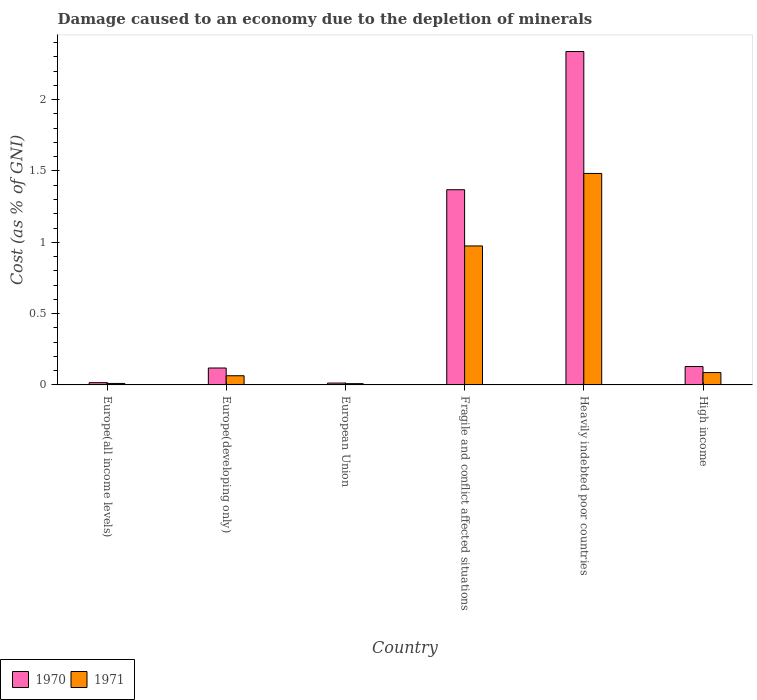How many different coloured bars are there?
Your answer should be compact. 2. Are the number of bars on each tick of the X-axis equal?
Provide a succinct answer. Yes. What is the label of the 4th group of bars from the left?
Your answer should be very brief. Fragile and conflict affected situations. What is the cost of damage caused due to the depletion of minerals in 1970 in Heavily indebted poor countries?
Keep it short and to the point. 2.34. Across all countries, what is the maximum cost of damage caused due to the depletion of minerals in 1971?
Make the answer very short. 1.48. Across all countries, what is the minimum cost of damage caused due to the depletion of minerals in 1971?
Ensure brevity in your answer.  0.01. In which country was the cost of damage caused due to the depletion of minerals in 1971 maximum?
Ensure brevity in your answer.  Heavily indebted poor countries. In which country was the cost of damage caused due to the depletion of minerals in 1971 minimum?
Give a very brief answer. European Union. What is the total cost of damage caused due to the depletion of minerals in 1971 in the graph?
Your answer should be very brief. 2.63. What is the difference between the cost of damage caused due to the depletion of minerals in 1970 in European Union and that in High income?
Your answer should be very brief. -0.12. What is the difference between the cost of damage caused due to the depletion of minerals in 1971 in Fragile and conflict affected situations and the cost of damage caused due to the depletion of minerals in 1970 in Europe(developing only)?
Make the answer very short. 0.86. What is the average cost of damage caused due to the depletion of minerals in 1971 per country?
Give a very brief answer. 0.44. What is the difference between the cost of damage caused due to the depletion of minerals of/in 1970 and cost of damage caused due to the depletion of minerals of/in 1971 in Heavily indebted poor countries?
Provide a succinct answer. 0.85. What is the ratio of the cost of damage caused due to the depletion of minerals in 1970 in Europe(all income levels) to that in High income?
Your answer should be compact. 0.12. Is the cost of damage caused due to the depletion of minerals in 1970 in Europe(developing only) less than that in Heavily indebted poor countries?
Offer a terse response. Yes. Is the difference between the cost of damage caused due to the depletion of minerals in 1970 in Europe(developing only) and European Union greater than the difference between the cost of damage caused due to the depletion of minerals in 1971 in Europe(developing only) and European Union?
Ensure brevity in your answer.  Yes. What is the difference between the highest and the second highest cost of damage caused due to the depletion of minerals in 1971?
Keep it short and to the point. -0.51. What is the difference between the highest and the lowest cost of damage caused due to the depletion of minerals in 1970?
Ensure brevity in your answer.  2.32. In how many countries, is the cost of damage caused due to the depletion of minerals in 1971 greater than the average cost of damage caused due to the depletion of minerals in 1971 taken over all countries?
Keep it short and to the point. 2. Is the sum of the cost of damage caused due to the depletion of minerals in 1970 in Europe(developing only) and High income greater than the maximum cost of damage caused due to the depletion of minerals in 1971 across all countries?
Offer a terse response. No. What does the 1st bar from the left in High income represents?
Offer a very short reply. 1970. Are all the bars in the graph horizontal?
Your answer should be very brief. No. What is the difference between two consecutive major ticks on the Y-axis?
Give a very brief answer. 0.5. Are the values on the major ticks of Y-axis written in scientific E-notation?
Keep it short and to the point. No. Does the graph contain grids?
Your answer should be compact. No. Where does the legend appear in the graph?
Provide a short and direct response. Bottom left. How many legend labels are there?
Ensure brevity in your answer.  2. How are the legend labels stacked?
Ensure brevity in your answer.  Horizontal. What is the title of the graph?
Keep it short and to the point. Damage caused to an economy due to the depletion of minerals. What is the label or title of the Y-axis?
Your answer should be very brief. Cost (as % of GNI). What is the Cost (as % of GNI) in 1970 in Europe(all income levels)?
Offer a very short reply. 0.02. What is the Cost (as % of GNI) in 1971 in Europe(all income levels)?
Your answer should be compact. 0.01. What is the Cost (as % of GNI) in 1970 in Europe(developing only)?
Provide a succinct answer. 0.12. What is the Cost (as % of GNI) in 1971 in Europe(developing only)?
Your response must be concise. 0.06. What is the Cost (as % of GNI) of 1970 in European Union?
Offer a very short reply. 0.01. What is the Cost (as % of GNI) in 1971 in European Union?
Ensure brevity in your answer.  0.01. What is the Cost (as % of GNI) in 1970 in Fragile and conflict affected situations?
Your answer should be compact. 1.37. What is the Cost (as % of GNI) of 1971 in Fragile and conflict affected situations?
Offer a terse response. 0.97. What is the Cost (as % of GNI) of 1970 in Heavily indebted poor countries?
Offer a very short reply. 2.34. What is the Cost (as % of GNI) of 1971 in Heavily indebted poor countries?
Keep it short and to the point. 1.48. What is the Cost (as % of GNI) of 1970 in High income?
Make the answer very short. 0.13. What is the Cost (as % of GNI) of 1971 in High income?
Provide a short and direct response. 0.09. Across all countries, what is the maximum Cost (as % of GNI) in 1970?
Offer a terse response. 2.34. Across all countries, what is the maximum Cost (as % of GNI) in 1971?
Your answer should be very brief. 1.48. Across all countries, what is the minimum Cost (as % of GNI) in 1970?
Offer a very short reply. 0.01. Across all countries, what is the minimum Cost (as % of GNI) in 1971?
Offer a very short reply. 0.01. What is the total Cost (as % of GNI) in 1970 in the graph?
Your answer should be very brief. 3.98. What is the total Cost (as % of GNI) of 1971 in the graph?
Make the answer very short. 2.63. What is the difference between the Cost (as % of GNI) of 1970 in Europe(all income levels) and that in Europe(developing only)?
Make the answer very short. -0.1. What is the difference between the Cost (as % of GNI) in 1971 in Europe(all income levels) and that in Europe(developing only)?
Give a very brief answer. -0.05. What is the difference between the Cost (as % of GNI) in 1970 in Europe(all income levels) and that in European Union?
Keep it short and to the point. 0. What is the difference between the Cost (as % of GNI) of 1971 in Europe(all income levels) and that in European Union?
Your response must be concise. 0. What is the difference between the Cost (as % of GNI) in 1970 in Europe(all income levels) and that in Fragile and conflict affected situations?
Provide a succinct answer. -1.35. What is the difference between the Cost (as % of GNI) in 1971 in Europe(all income levels) and that in Fragile and conflict affected situations?
Give a very brief answer. -0.96. What is the difference between the Cost (as % of GNI) in 1970 in Europe(all income levels) and that in Heavily indebted poor countries?
Your answer should be compact. -2.32. What is the difference between the Cost (as % of GNI) of 1971 in Europe(all income levels) and that in Heavily indebted poor countries?
Your response must be concise. -1.47. What is the difference between the Cost (as % of GNI) of 1970 in Europe(all income levels) and that in High income?
Keep it short and to the point. -0.11. What is the difference between the Cost (as % of GNI) of 1971 in Europe(all income levels) and that in High income?
Your answer should be compact. -0.08. What is the difference between the Cost (as % of GNI) in 1970 in Europe(developing only) and that in European Union?
Provide a succinct answer. 0.11. What is the difference between the Cost (as % of GNI) of 1971 in Europe(developing only) and that in European Union?
Your answer should be very brief. 0.06. What is the difference between the Cost (as % of GNI) of 1970 in Europe(developing only) and that in Fragile and conflict affected situations?
Your answer should be compact. -1.25. What is the difference between the Cost (as % of GNI) in 1971 in Europe(developing only) and that in Fragile and conflict affected situations?
Offer a very short reply. -0.91. What is the difference between the Cost (as % of GNI) of 1970 in Europe(developing only) and that in Heavily indebted poor countries?
Keep it short and to the point. -2.22. What is the difference between the Cost (as % of GNI) in 1971 in Europe(developing only) and that in Heavily indebted poor countries?
Your answer should be very brief. -1.42. What is the difference between the Cost (as % of GNI) in 1970 in Europe(developing only) and that in High income?
Your answer should be very brief. -0.01. What is the difference between the Cost (as % of GNI) in 1971 in Europe(developing only) and that in High income?
Keep it short and to the point. -0.02. What is the difference between the Cost (as % of GNI) of 1970 in European Union and that in Fragile and conflict affected situations?
Make the answer very short. -1.36. What is the difference between the Cost (as % of GNI) of 1971 in European Union and that in Fragile and conflict affected situations?
Your response must be concise. -0.97. What is the difference between the Cost (as % of GNI) in 1970 in European Union and that in Heavily indebted poor countries?
Your answer should be very brief. -2.32. What is the difference between the Cost (as % of GNI) of 1971 in European Union and that in Heavily indebted poor countries?
Your response must be concise. -1.47. What is the difference between the Cost (as % of GNI) in 1970 in European Union and that in High income?
Make the answer very short. -0.12. What is the difference between the Cost (as % of GNI) in 1971 in European Union and that in High income?
Your response must be concise. -0.08. What is the difference between the Cost (as % of GNI) in 1970 in Fragile and conflict affected situations and that in Heavily indebted poor countries?
Offer a terse response. -0.97. What is the difference between the Cost (as % of GNI) in 1971 in Fragile and conflict affected situations and that in Heavily indebted poor countries?
Your answer should be very brief. -0.51. What is the difference between the Cost (as % of GNI) of 1970 in Fragile and conflict affected situations and that in High income?
Offer a very short reply. 1.24. What is the difference between the Cost (as % of GNI) in 1971 in Fragile and conflict affected situations and that in High income?
Your answer should be very brief. 0.89. What is the difference between the Cost (as % of GNI) in 1970 in Heavily indebted poor countries and that in High income?
Your answer should be compact. 2.21. What is the difference between the Cost (as % of GNI) of 1971 in Heavily indebted poor countries and that in High income?
Provide a succinct answer. 1.4. What is the difference between the Cost (as % of GNI) in 1970 in Europe(all income levels) and the Cost (as % of GNI) in 1971 in Europe(developing only)?
Provide a short and direct response. -0.05. What is the difference between the Cost (as % of GNI) in 1970 in Europe(all income levels) and the Cost (as % of GNI) in 1971 in European Union?
Give a very brief answer. 0.01. What is the difference between the Cost (as % of GNI) in 1970 in Europe(all income levels) and the Cost (as % of GNI) in 1971 in Fragile and conflict affected situations?
Your response must be concise. -0.96. What is the difference between the Cost (as % of GNI) of 1970 in Europe(all income levels) and the Cost (as % of GNI) of 1971 in Heavily indebted poor countries?
Give a very brief answer. -1.47. What is the difference between the Cost (as % of GNI) of 1970 in Europe(all income levels) and the Cost (as % of GNI) of 1971 in High income?
Your answer should be compact. -0.07. What is the difference between the Cost (as % of GNI) in 1970 in Europe(developing only) and the Cost (as % of GNI) in 1971 in European Union?
Your answer should be compact. 0.11. What is the difference between the Cost (as % of GNI) in 1970 in Europe(developing only) and the Cost (as % of GNI) in 1971 in Fragile and conflict affected situations?
Provide a short and direct response. -0.86. What is the difference between the Cost (as % of GNI) in 1970 in Europe(developing only) and the Cost (as % of GNI) in 1971 in Heavily indebted poor countries?
Provide a short and direct response. -1.36. What is the difference between the Cost (as % of GNI) of 1970 in Europe(developing only) and the Cost (as % of GNI) of 1971 in High income?
Offer a terse response. 0.03. What is the difference between the Cost (as % of GNI) in 1970 in European Union and the Cost (as % of GNI) in 1971 in Fragile and conflict affected situations?
Offer a terse response. -0.96. What is the difference between the Cost (as % of GNI) in 1970 in European Union and the Cost (as % of GNI) in 1971 in Heavily indebted poor countries?
Ensure brevity in your answer.  -1.47. What is the difference between the Cost (as % of GNI) in 1970 in European Union and the Cost (as % of GNI) in 1971 in High income?
Offer a very short reply. -0.07. What is the difference between the Cost (as % of GNI) of 1970 in Fragile and conflict affected situations and the Cost (as % of GNI) of 1971 in Heavily indebted poor countries?
Provide a short and direct response. -0.11. What is the difference between the Cost (as % of GNI) of 1970 in Fragile and conflict affected situations and the Cost (as % of GNI) of 1971 in High income?
Keep it short and to the point. 1.28. What is the difference between the Cost (as % of GNI) in 1970 in Heavily indebted poor countries and the Cost (as % of GNI) in 1971 in High income?
Offer a very short reply. 2.25. What is the average Cost (as % of GNI) of 1970 per country?
Give a very brief answer. 0.66. What is the average Cost (as % of GNI) of 1971 per country?
Offer a very short reply. 0.44. What is the difference between the Cost (as % of GNI) of 1970 and Cost (as % of GNI) of 1971 in Europe(all income levels)?
Offer a terse response. 0.01. What is the difference between the Cost (as % of GNI) in 1970 and Cost (as % of GNI) in 1971 in Europe(developing only)?
Provide a short and direct response. 0.05. What is the difference between the Cost (as % of GNI) in 1970 and Cost (as % of GNI) in 1971 in European Union?
Your answer should be compact. 0. What is the difference between the Cost (as % of GNI) of 1970 and Cost (as % of GNI) of 1971 in Fragile and conflict affected situations?
Give a very brief answer. 0.39. What is the difference between the Cost (as % of GNI) in 1970 and Cost (as % of GNI) in 1971 in Heavily indebted poor countries?
Provide a succinct answer. 0.85. What is the difference between the Cost (as % of GNI) of 1970 and Cost (as % of GNI) of 1971 in High income?
Give a very brief answer. 0.04. What is the ratio of the Cost (as % of GNI) of 1970 in Europe(all income levels) to that in Europe(developing only)?
Ensure brevity in your answer.  0.13. What is the ratio of the Cost (as % of GNI) in 1971 in Europe(all income levels) to that in Europe(developing only)?
Your answer should be very brief. 0.16. What is the ratio of the Cost (as % of GNI) in 1970 in Europe(all income levels) to that in European Union?
Make the answer very short. 1.22. What is the ratio of the Cost (as % of GNI) of 1971 in Europe(all income levels) to that in European Union?
Your answer should be very brief. 1.16. What is the ratio of the Cost (as % of GNI) of 1970 in Europe(all income levels) to that in Fragile and conflict affected situations?
Make the answer very short. 0.01. What is the ratio of the Cost (as % of GNI) of 1971 in Europe(all income levels) to that in Fragile and conflict affected situations?
Ensure brevity in your answer.  0.01. What is the ratio of the Cost (as % of GNI) of 1970 in Europe(all income levels) to that in Heavily indebted poor countries?
Your response must be concise. 0.01. What is the ratio of the Cost (as % of GNI) in 1971 in Europe(all income levels) to that in Heavily indebted poor countries?
Provide a short and direct response. 0.01. What is the ratio of the Cost (as % of GNI) of 1970 in Europe(all income levels) to that in High income?
Provide a short and direct response. 0.12. What is the ratio of the Cost (as % of GNI) in 1971 in Europe(all income levels) to that in High income?
Keep it short and to the point. 0.12. What is the ratio of the Cost (as % of GNI) of 1970 in Europe(developing only) to that in European Union?
Make the answer very short. 9.17. What is the ratio of the Cost (as % of GNI) of 1971 in Europe(developing only) to that in European Union?
Give a very brief answer. 7.27. What is the ratio of the Cost (as % of GNI) in 1970 in Europe(developing only) to that in Fragile and conflict affected situations?
Your answer should be very brief. 0.09. What is the ratio of the Cost (as % of GNI) of 1971 in Europe(developing only) to that in Fragile and conflict affected situations?
Ensure brevity in your answer.  0.07. What is the ratio of the Cost (as % of GNI) of 1970 in Europe(developing only) to that in Heavily indebted poor countries?
Offer a terse response. 0.05. What is the ratio of the Cost (as % of GNI) in 1971 in Europe(developing only) to that in Heavily indebted poor countries?
Provide a succinct answer. 0.04. What is the ratio of the Cost (as % of GNI) in 1970 in Europe(developing only) to that in High income?
Your answer should be very brief. 0.92. What is the ratio of the Cost (as % of GNI) of 1971 in Europe(developing only) to that in High income?
Provide a succinct answer. 0.74. What is the ratio of the Cost (as % of GNI) in 1970 in European Union to that in Fragile and conflict affected situations?
Provide a succinct answer. 0.01. What is the ratio of the Cost (as % of GNI) in 1971 in European Union to that in Fragile and conflict affected situations?
Your answer should be very brief. 0.01. What is the ratio of the Cost (as % of GNI) in 1970 in European Union to that in Heavily indebted poor countries?
Your answer should be very brief. 0.01. What is the ratio of the Cost (as % of GNI) of 1971 in European Union to that in Heavily indebted poor countries?
Your answer should be compact. 0.01. What is the ratio of the Cost (as % of GNI) of 1970 in European Union to that in High income?
Your response must be concise. 0.1. What is the ratio of the Cost (as % of GNI) in 1971 in European Union to that in High income?
Your answer should be compact. 0.1. What is the ratio of the Cost (as % of GNI) of 1970 in Fragile and conflict affected situations to that in Heavily indebted poor countries?
Your answer should be very brief. 0.59. What is the ratio of the Cost (as % of GNI) in 1971 in Fragile and conflict affected situations to that in Heavily indebted poor countries?
Make the answer very short. 0.66. What is the ratio of the Cost (as % of GNI) in 1970 in Fragile and conflict affected situations to that in High income?
Keep it short and to the point. 10.63. What is the ratio of the Cost (as % of GNI) in 1971 in Fragile and conflict affected situations to that in High income?
Ensure brevity in your answer.  11.26. What is the ratio of the Cost (as % of GNI) in 1970 in Heavily indebted poor countries to that in High income?
Offer a very short reply. 18.15. What is the ratio of the Cost (as % of GNI) in 1971 in Heavily indebted poor countries to that in High income?
Your response must be concise. 17.13. What is the difference between the highest and the second highest Cost (as % of GNI) in 1970?
Provide a succinct answer. 0.97. What is the difference between the highest and the second highest Cost (as % of GNI) of 1971?
Offer a terse response. 0.51. What is the difference between the highest and the lowest Cost (as % of GNI) of 1970?
Keep it short and to the point. 2.32. What is the difference between the highest and the lowest Cost (as % of GNI) of 1971?
Provide a succinct answer. 1.47. 